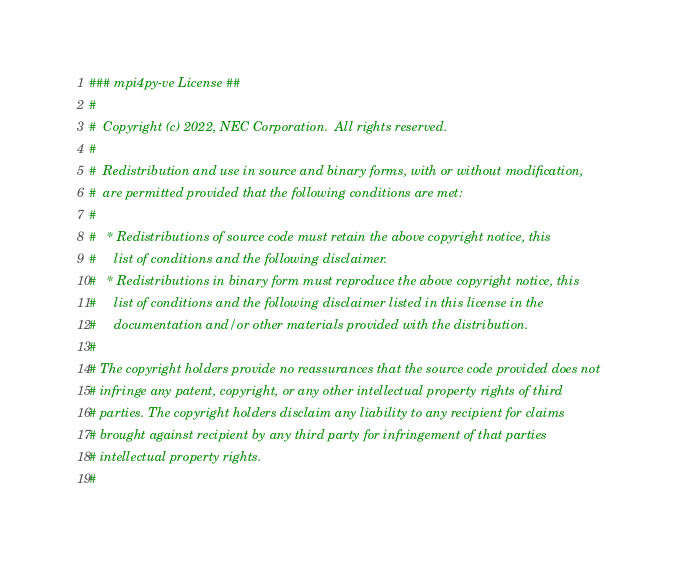<code> <loc_0><loc_0><loc_500><loc_500><_Cython_>### mpi4py-ve License ##
#
#  Copyright (c) 2022, NEC Corporation.  All rights reserved.
#
#  Redistribution and use in source and binary forms, with or without modification,
#  are permitted provided that the following conditions are met:
#
#   * Redistributions of source code must retain the above copyright notice, this
#     list of conditions and the following disclaimer.
#   * Redistributions in binary form must reproduce the above copyright notice, this
#     list of conditions and the following disclaimer listed in this license in the
#     documentation and/or other materials provided with the distribution.
#
# The copyright holders provide no reassurances that the source code provided does not
# infringe any patent, copyright, or any other intellectual property rights of third
# parties. The copyright holders disclaim any liability to any recipient for claims
# brought against recipient by any third party for infringement of that parties
# intellectual property rights.
#</code> 